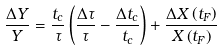Convert formula to latex. <formula><loc_0><loc_0><loc_500><loc_500>\frac { \Delta Y } Y = \frac { t _ { c } } \tau \left ( \frac { \Delta \tau } \tau - \frac { \Delta t _ { c } } { t _ { c } } \right ) + \frac { \Delta X \left ( t _ { F } \right ) } { X \left ( t _ { F } \right ) }</formula> 